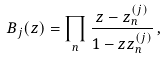Convert formula to latex. <formula><loc_0><loc_0><loc_500><loc_500>B _ { j } ( z ) = \prod _ { n } \frac { z - z _ { n } ^ { ( j ) } } { 1 - z z _ { n } ^ { ( j ) } } \, ,</formula> 